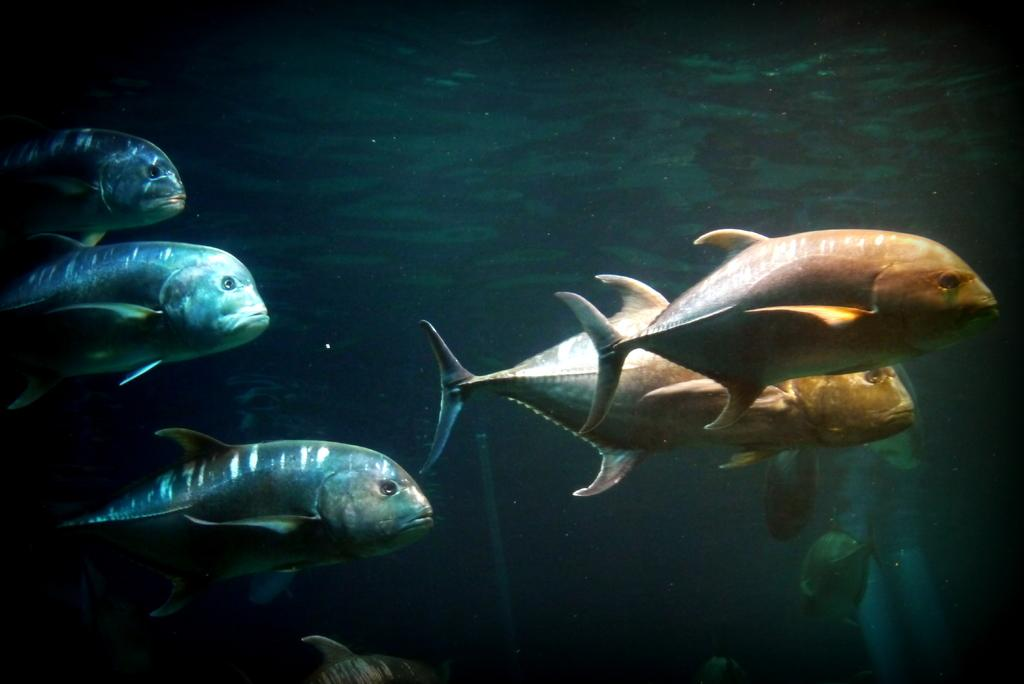What is the primary element in the picture? There is water in the picture. What can be found within the water? There are many fishes present in the water. What type of comfort can be seen in the picture? There is no reference to comfort in the image, as it features water and fishes. What song is being sung by the fishes in the picture? There is no indication of any song being sung by the fishes in the image. 